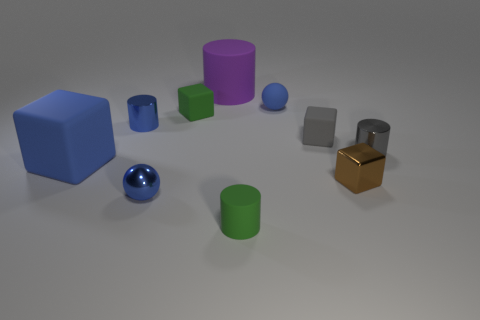Is the number of tiny green matte spheres greater than the number of green rubber things?
Ensure brevity in your answer.  No. What number of cylinders are tiny green matte things or big blue matte things?
Provide a succinct answer. 1. The large rubber cylinder has what color?
Give a very brief answer. Purple. There is a green object in front of the tiny gray rubber block; does it have the same size as the blue ball behind the tiny brown metal cube?
Keep it short and to the point. Yes. Are there fewer blue objects than small blue spheres?
Offer a very short reply. No. There is a matte sphere; how many shiny spheres are to the left of it?
Provide a short and direct response. 1. What material is the big blue object?
Your answer should be compact. Rubber. Is the color of the metallic sphere the same as the tiny matte cylinder?
Give a very brief answer. No. Is the number of tiny metal objects that are on the right side of the large block less than the number of tiny rubber objects?
Offer a terse response. No. What is the color of the large thing that is behind the big blue rubber thing?
Make the answer very short. Purple. 